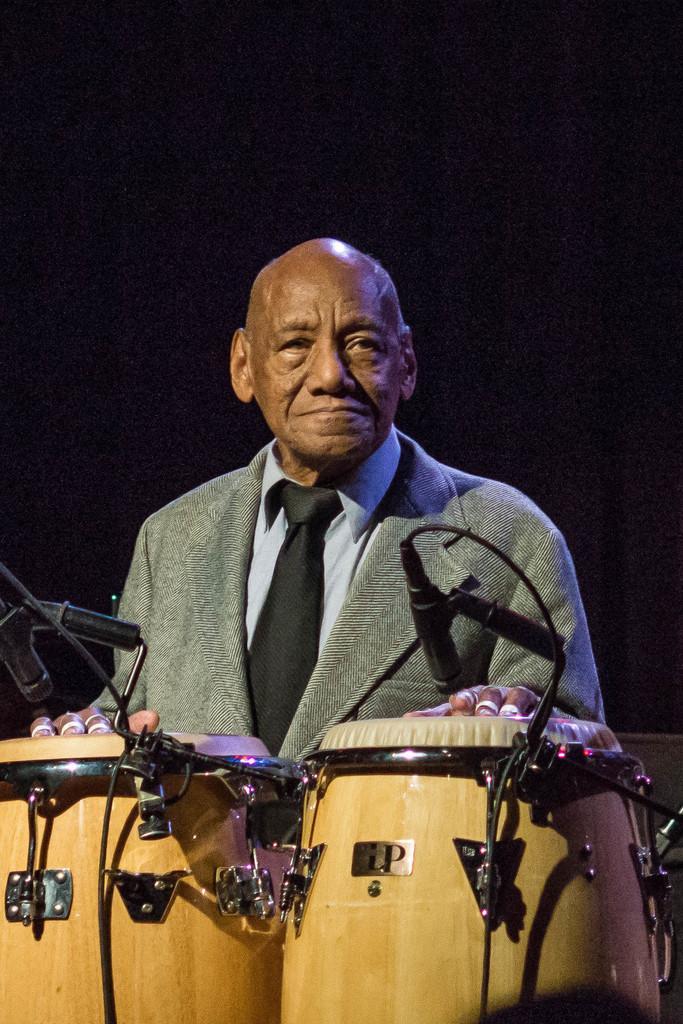Please provide a concise description of this image. This man wore suit and tie is standing. In-front of this man there are musical drums. This is a mic with mic holder. 